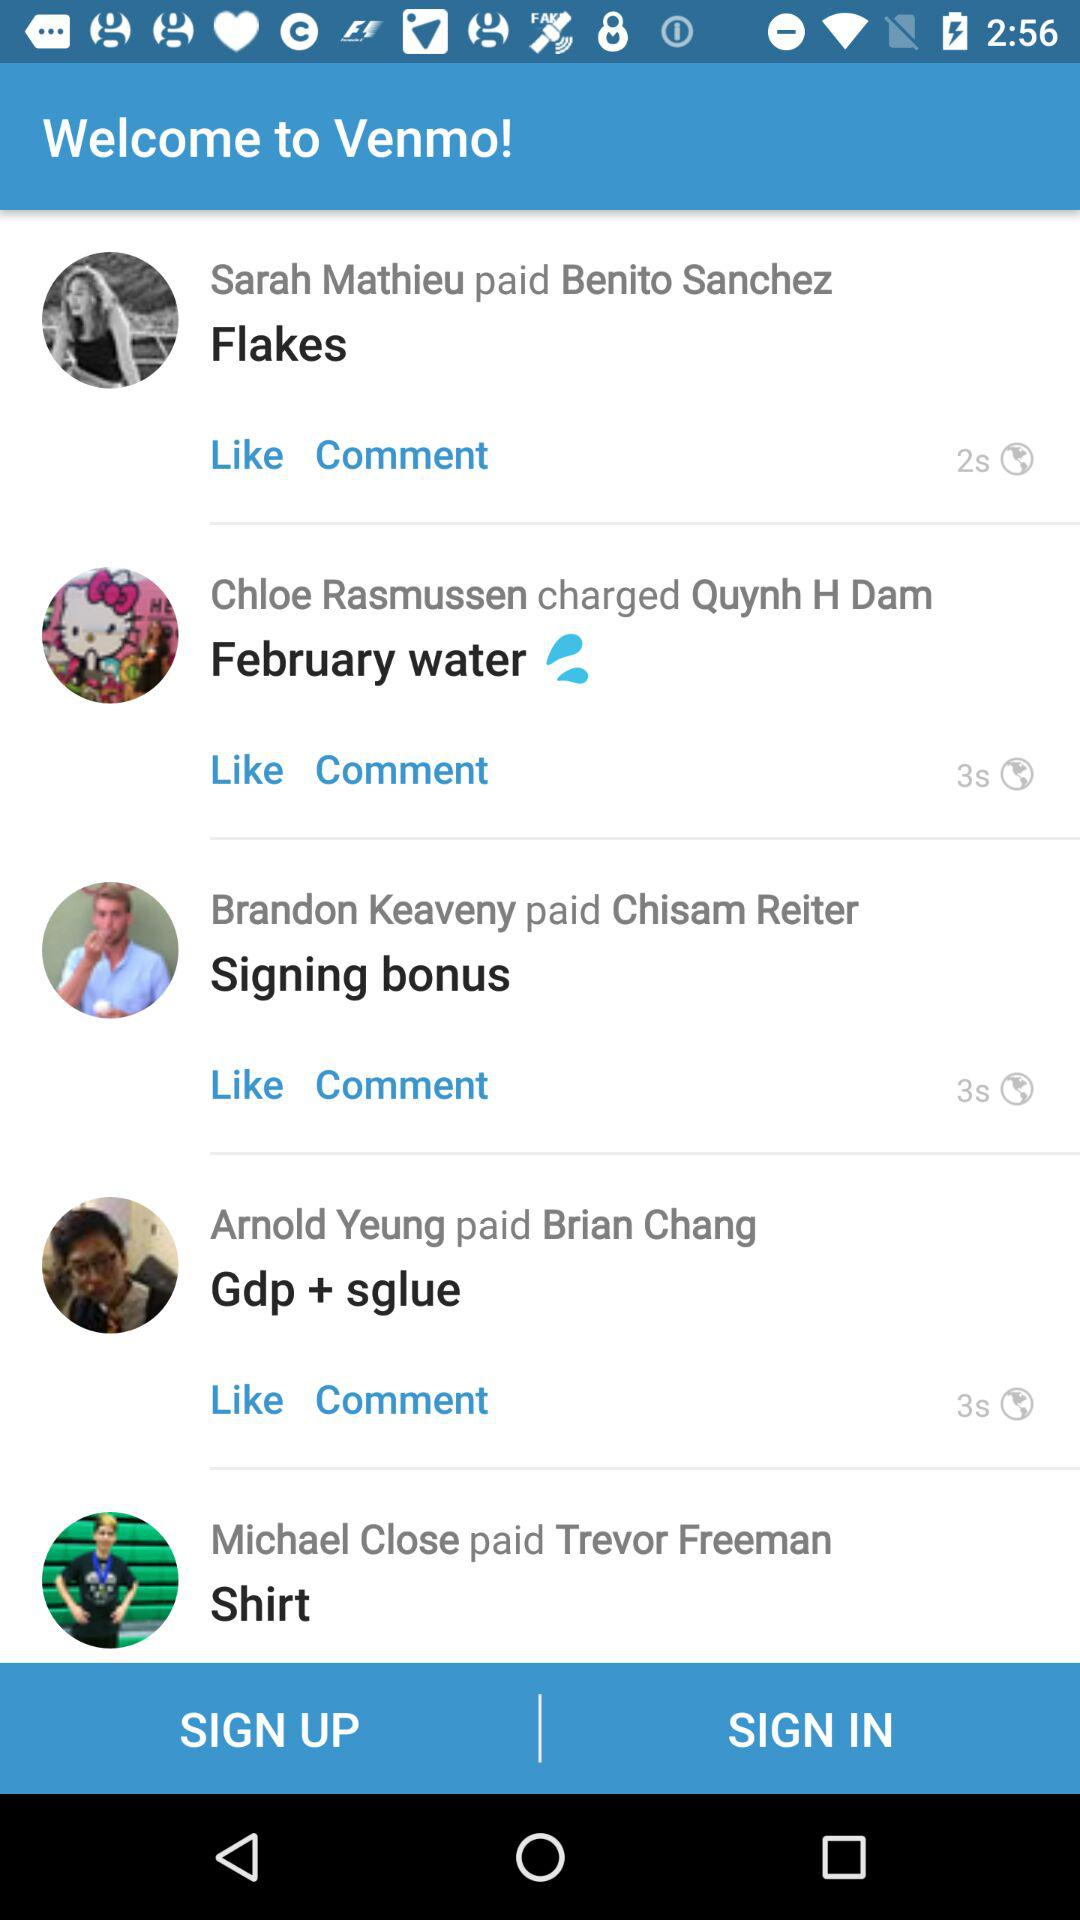Who writes flakes in comments?
When the provided information is insufficient, respond with <no answer>. <no answer> 